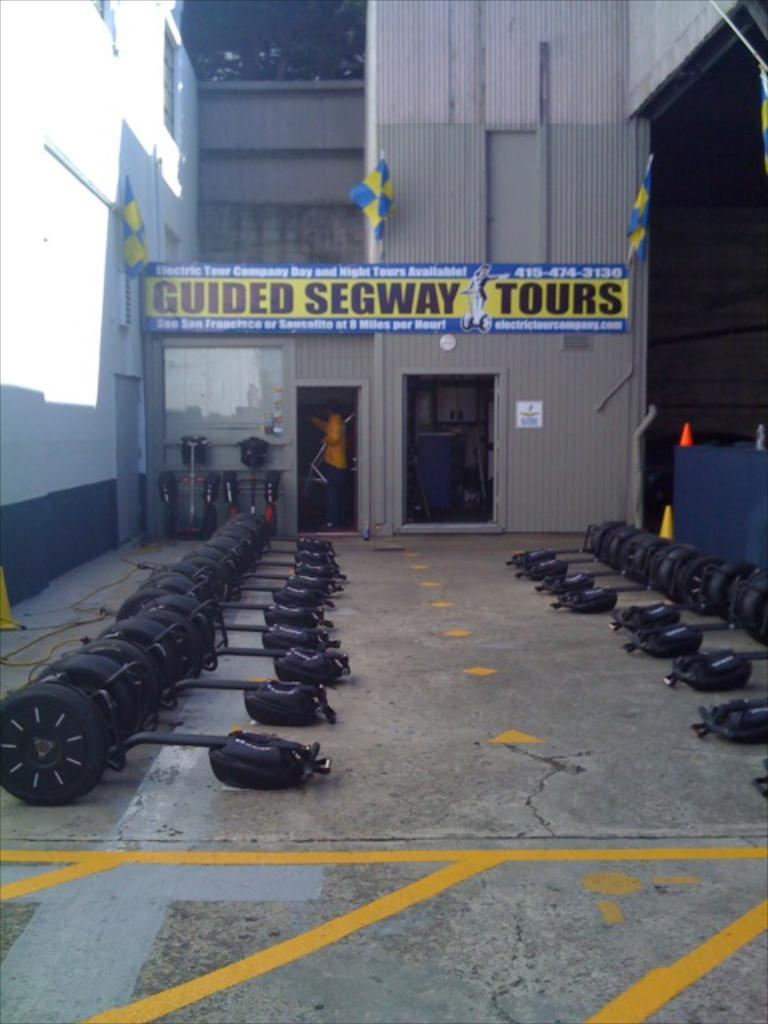What type of vehicles are on the ground in the image? There are black color unicycles on the ground. What else can be seen in the image besides the unicycles? There is a banner visible in the image. What type of marble is used to decorate the wave in the image? There is no marble or wave present in the image; it features black color unicycles and a banner. 